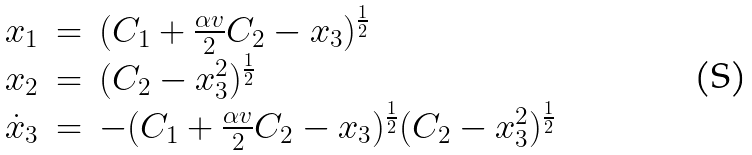<formula> <loc_0><loc_0><loc_500><loc_500>\begin{array} { l l l } x _ { 1 } & = & ( C _ { 1 } + \frac { \alpha v } { 2 } C _ { 2 } - x _ { 3 } ) ^ { \frac { 1 } { 2 } } \\ x _ { 2 } & = & ( C _ { 2 } - x _ { 3 } ^ { 2 } ) ^ { \frac { 1 } { 2 } } \\ \dot { x } _ { 3 } & = & - ( C _ { 1 } + \frac { \alpha v } { 2 } C _ { 2 } - x _ { 3 } ) ^ { \frac { 1 } { 2 } } ( C _ { 2 } - x _ { 3 } ^ { 2 } ) ^ { \frac { 1 } { 2 } } \\ \end{array}</formula> 